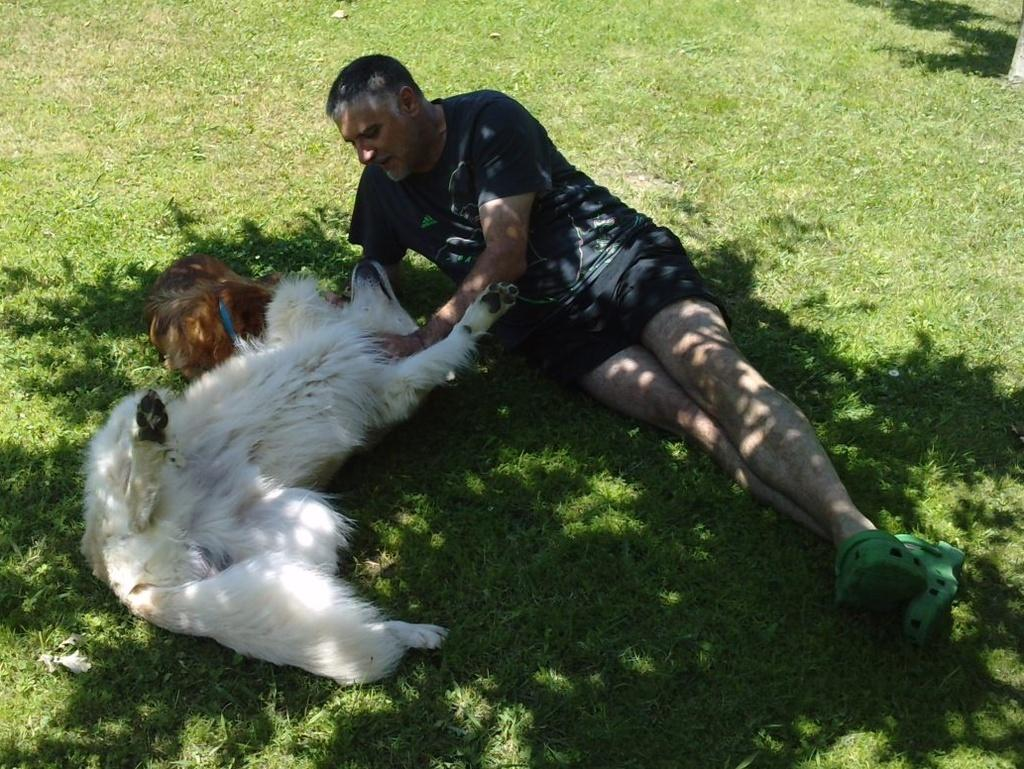What is the main subject of the image? The main subject of the image is a man. What is the man doing in the image? The man is laying on the floor. Are there any other living beings in the image? Yes, there is a dog in the image. What is the dog doing in the image? The dog is also laying on the floor. What is the price of the bears in the image? There are no bears present in the image, so it is not possible to determine the price of any bears. 